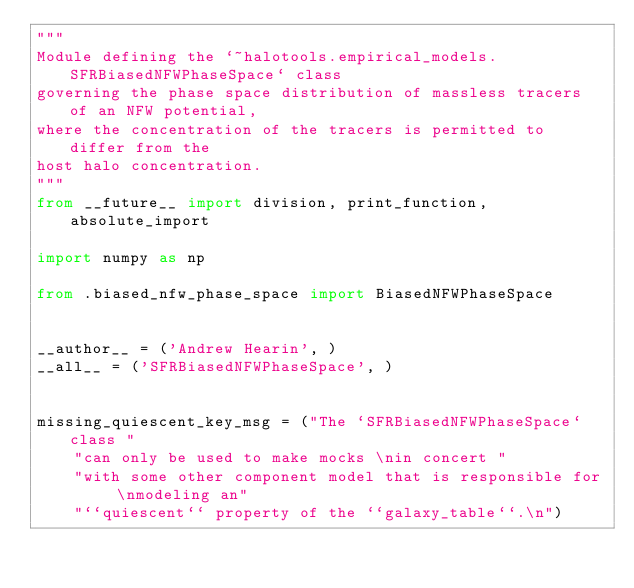<code> <loc_0><loc_0><loc_500><loc_500><_Python_>"""
Module defining the `~halotools.empirical_models.SFRBiasedNFWPhaseSpace` class
governing the phase space distribution of massless tracers of an NFW potential,
where the concentration of the tracers is permitted to differ from the
host halo concentration.
"""
from __future__ import division, print_function, absolute_import

import numpy as np

from .biased_nfw_phase_space import BiasedNFWPhaseSpace


__author__ = ('Andrew Hearin', )
__all__ = ('SFRBiasedNFWPhaseSpace', )


missing_quiescent_key_msg = ("The `SFRBiasedNFWPhaseSpace` class "
    "can only be used to make mocks \nin concert "
    "with some other component model that is responsible for \nmodeling an"
    "``quiescent`` property of the ``galaxy_table``.\n")

</code> 